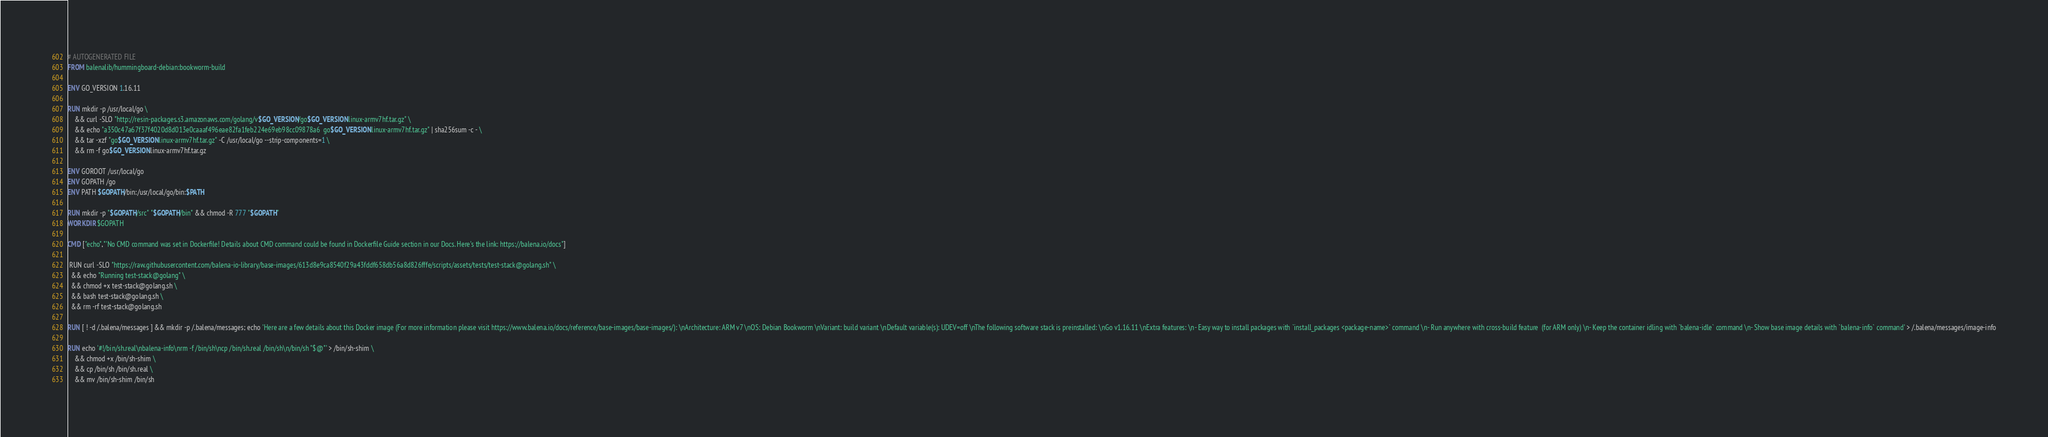<code> <loc_0><loc_0><loc_500><loc_500><_Dockerfile_># AUTOGENERATED FILE
FROM balenalib/hummingboard-debian:bookworm-build

ENV GO_VERSION 1.16.11

RUN mkdir -p /usr/local/go \
	&& curl -SLO "http://resin-packages.s3.amazonaws.com/golang/v$GO_VERSION/go$GO_VERSION.linux-armv7hf.tar.gz" \
	&& echo "a350c47a67f37f4020d8d013e0caaaf496eae82fa1feb224e69eb98cc09878a6  go$GO_VERSION.linux-armv7hf.tar.gz" | sha256sum -c - \
	&& tar -xzf "go$GO_VERSION.linux-armv7hf.tar.gz" -C /usr/local/go --strip-components=1 \
	&& rm -f go$GO_VERSION.linux-armv7hf.tar.gz

ENV GOROOT /usr/local/go
ENV GOPATH /go
ENV PATH $GOPATH/bin:/usr/local/go/bin:$PATH

RUN mkdir -p "$GOPATH/src" "$GOPATH/bin" && chmod -R 777 "$GOPATH"
WORKDIR $GOPATH

CMD ["echo","'No CMD command was set in Dockerfile! Details about CMD command could be found in Dockerfile Guide section in our Docs. Here's the link: https://balena.io/docs"]

 RUN curl -SLO "https://raw.githubusercontent.com/balena-io-library/base-images/613d8e9ca8540f29a43fddf658db56a8d826fffe/scripts/assets/tests/test-stack@golang.sh" \
  && echo "Running test-stack@golang" \
  && chmod +x test-stack@golang.sh \
  && bash test-stack@golang.sh \
  && rm -rf test-stack@golang.sh 

RUN [ ! -d /.balena/messages ] && mkdir -p /.balena/messages; echo 'Here are a few details about this Docker image (For more information please visit https://www.balena.io/docs/reference/base-images/base-images/): \nArchitecture: ARM v7 \nOS: Debian Bookworm \nVariant: build variant \nDefault variable(s): UDEV=off \nThe following software stack is preinstalled: \nGo v1.16.11 \nExtra features: \n- Easy way to install packages with `install_packages <package-name>` command \n- Run anywhere with cross-build feature  (for ARM only) \n- Keep the container idling with `balena-idle` command \n- Show base image details with `balena-info` command' > /.balena/messages/image-info

RUN echo '#!/bin/sh.real\nbalena-info\nrm -f /bin/sh\ncp /bin/sh.real /bin/sh\n/bin/sh "$@"' > /bin/sh-shim \
	&& chmod +x /bin/sh-shim \
	&& cp /bin/sh /bin/sh.real \
	&& mv /bin/sh-shim /bin/sh</code> 